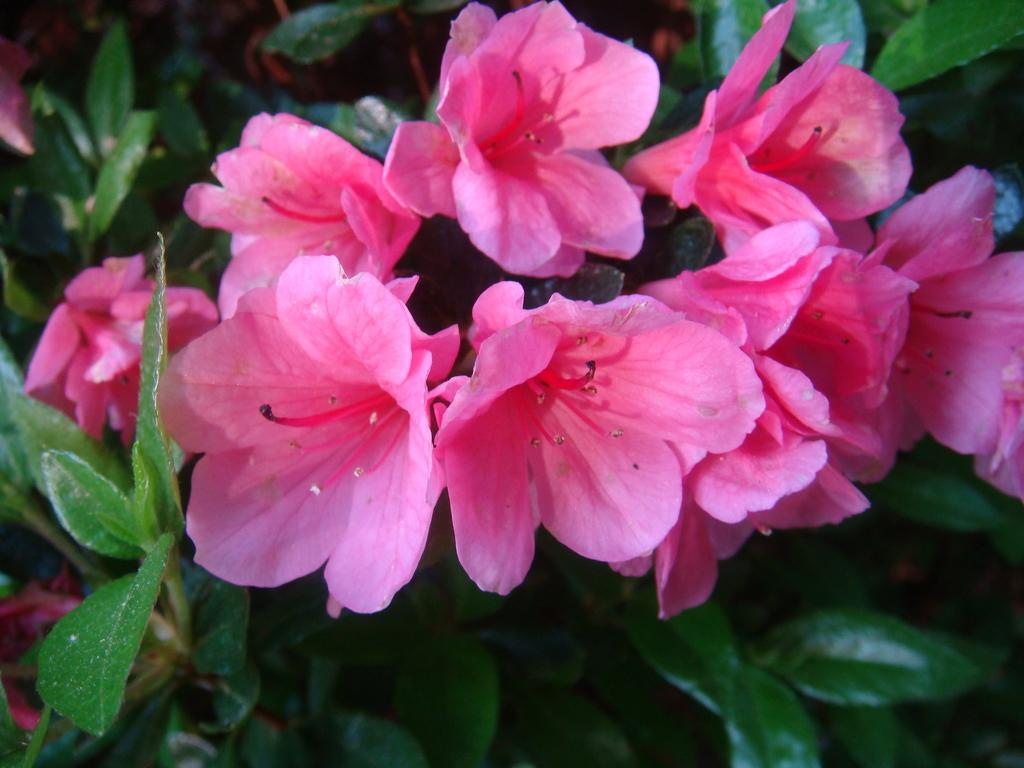What is the main subject of the image? The main subject of the image is plants. Can you describe the plants in the image? There are pink color flowers in the image. What type of zephyr can be seen blowing through the flowers in the image? There is no zephyr present in the image, and therefore no such activity can be observed. 